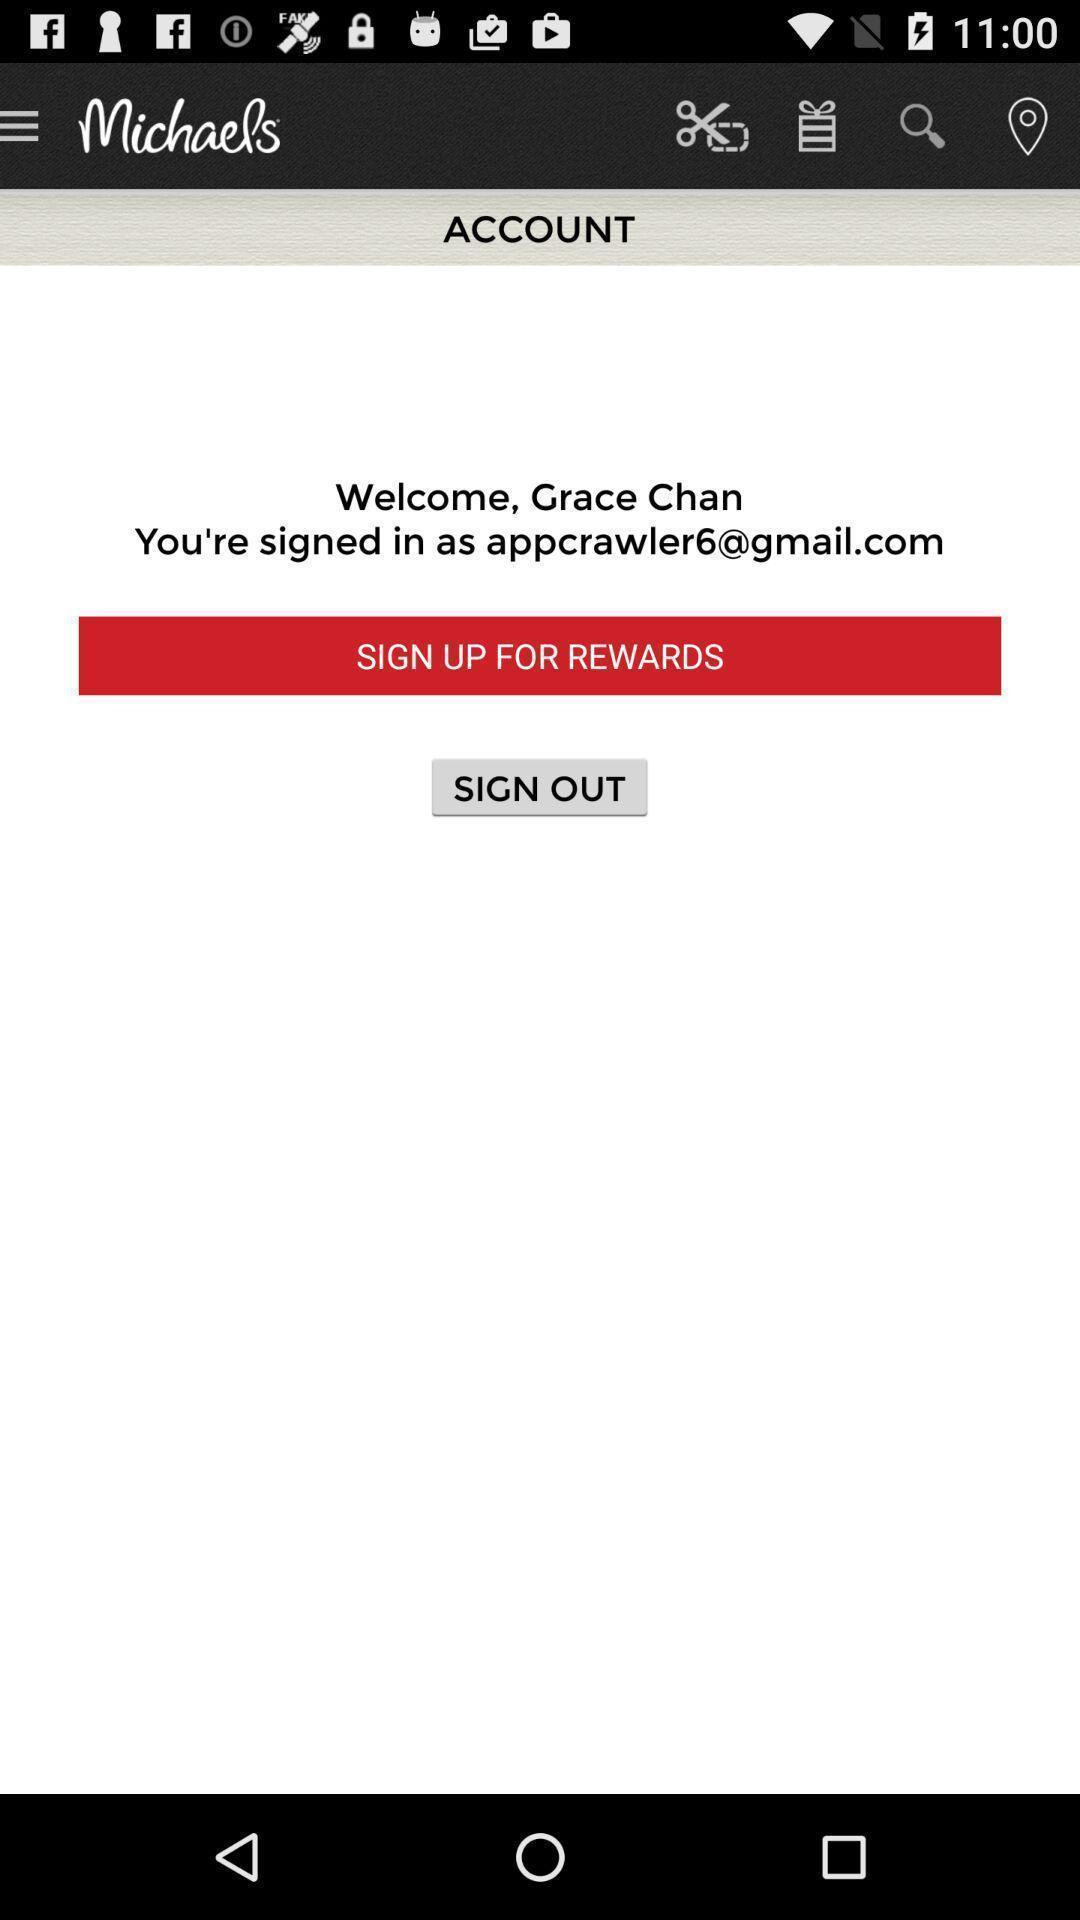Explain the elements present in this screenshot. Sign up and sign out page for the account. 